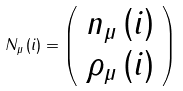<formula> <loc_0><loc_0><loc_500><loc_500>N _ { \mu } \left ( i \right ) = \left ( \begin{array} { c } n _ { \mu } \left ( i \right ) \\ \rho _ { \mu } \left ( i \right ) \end{array} \right )</formula> 